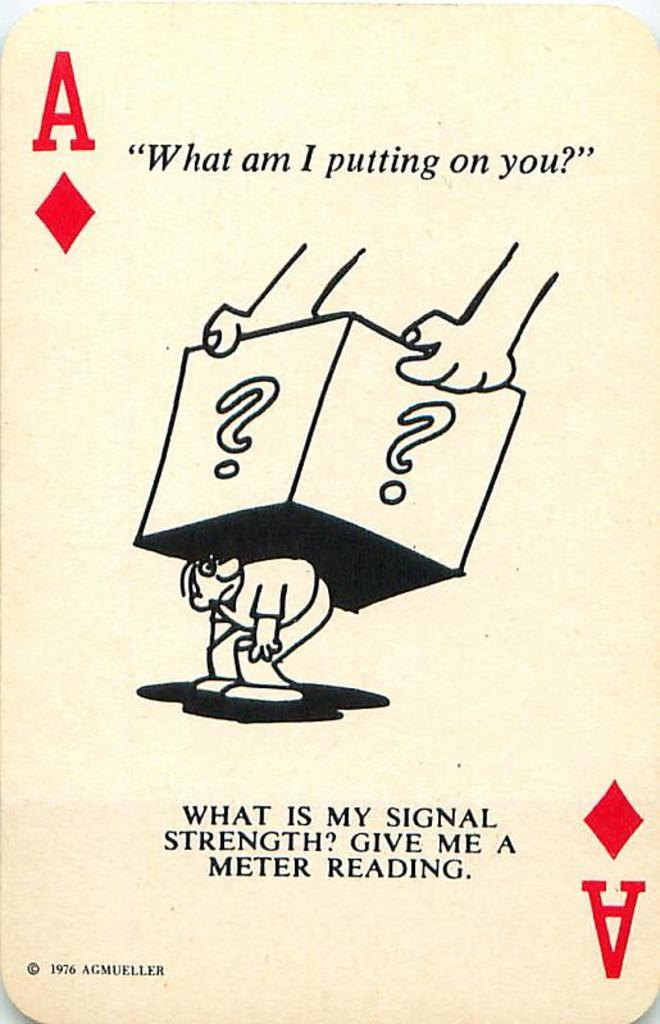<image>
Relay a brief, clear account of the picture shown. A cartoon from 1976 features the phrase "What am I putting on you?" 